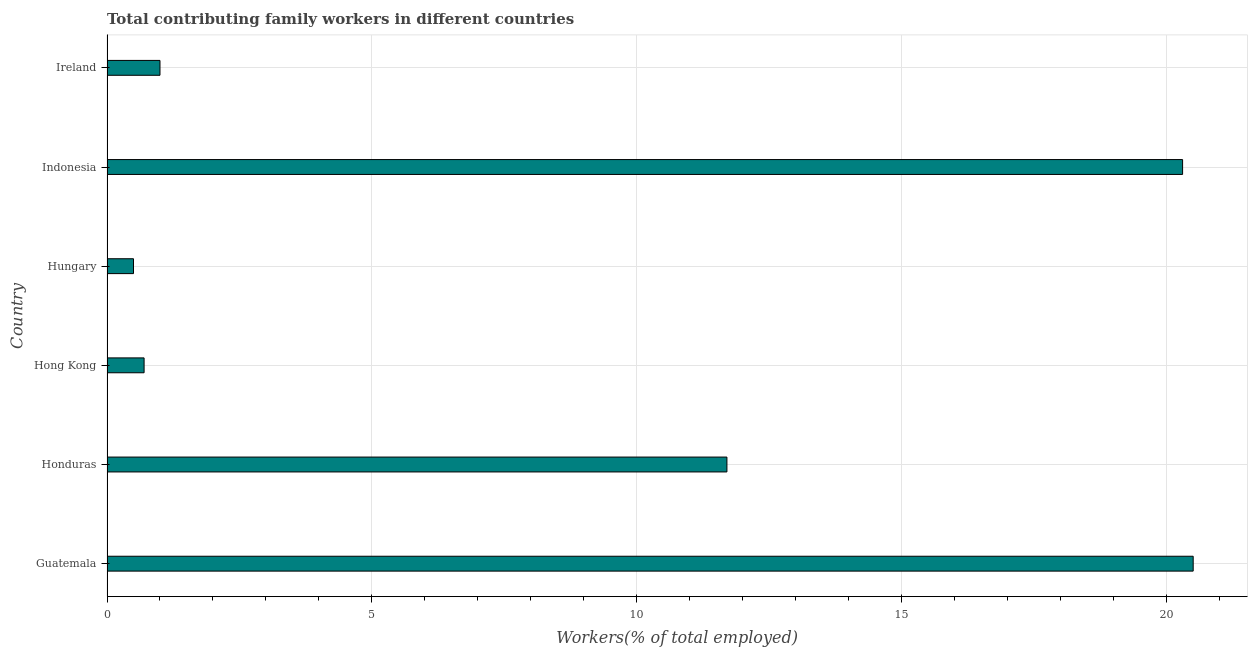Does the graph contain any zero values?
Keep it short and to the point. No. Does the graph contain grids?
Make the answer very short. Yes. What is the title of the graph?
Make the answer very short. Total contributing family workers in different countries. What is the label or title of the X-axis?
Offer a terse response. Workers(% of total employed). What is the contributing family workers in Hong Kong?
Keep it short and to the point. 0.7. Across all countries, what is the maximum contributing family workers?
Ensure brevity in your answer.  20.5. Across all countries, what is the minimum contributing family workers?
Ensure brevity in your answer.  0.5. In which country was the contributing family workers maximum?
Provide a short and direct response. Guatemala. In which country was the contributing family workers minimum?
Your response must be concise. Hungary. What is the sum of the contributing family workers?
Your answer should be compact. 54.7. What is the difference between the contributing family workers in Indonesia and Ireland?
Ensure brevity in your answer.  19.3. What is the average contributing family workers per country?
Your response must be concise. 9.12. What is the median contributing family workers?
Your answer should be compact. 6.35. What is the ratio of the contributing family workers in Guatemala to that in Ireland?
Keep it short and to the point. 20.5. Is the difference between the contributing family workers in Guatemala and Hungary greater than the difference between any two countries?
Ensure brevity in your answer.  Yes. What is the difference between the highest and the second highest contributing family workers?
Provide a succinct answer. 0.2. What is the difference between the highest and the lowest contributing family workers?
Keep it short and to the point. 20. In how many countries, is the contributing family workers greater than the average contributing family workers taken over all countries?
Your answer should be very brief. 3. How many bars are there?
Your response must be concise. 6. How many countries are there in the graph?
Provide a succinct answer. 6. What is the difference between two consecutive major ticks on the X-axis?
Offer a terse response. 5. Are the values on the major ticks of X-axis written in scientific E-notation?
Keep it short and to the point. No. What is the Workers(% of total employed) of Honduras?
Your answer should be very brief. 11.7. What is the Workers(% of total employed) in Hong Kong?
Ensure brevity in your answer.  0.7. What is the Workers(% of total employed) in Indonesia?
Offer a terse response. 20.3. What is the difference between the Workers(% of total employed) in Guatemala and Honduras?
Offer a terse response. 8.8. What is the difference between the Workers(% of total employed) in Guatemala and Hong Kong?
Your answer should be compact. 19.8. What is the difference between the Workers(% of total employed) in Guatemala and Hungary?
Your answer should be compact. 20. What is the difference between the Workers(% of total employed) in Guatemala and Ireland?
Your response must be concise. 19.5. What is the difference between the Workers(% of total employed) in Honduras and Hungary?
Keep it short and to the point. 11.2. What is the difference between the Workers(% of total employed) in Hong Kong and Indonesia?
Keep it short and to the point. -19.6. What is the difference between the Workers(% of total employed) in Hong Kong and Ireland?
Provide a succinct answer. -0.3. What is the difference between the Workers(% of total employed) in Hungary and Indonesia?
Provide a short and direct response. -19.8. What is the difference between the Workers(% of total employed) in Indonesia and Ireland?
Your answer should be very brief. 19.3. What is the ratio of the Workers(% of total employed) in Guatemala to that in Honduras?
Your response must be concise. 1.75. What is the ratio of the Workers(% of total employed) in Guatemala to that in Hong Kong?
Your response must be concise. 29.29. What is the ratio of the Workers(% of total employed) in Guatemala to that in Ireland?
Your answer should be compact. 20.5. What is the ratio of the Workers(% of total employed) in Honduras to that in Hong Kong?
Your answer should be compact. 16.71. What is the ratio of the Workers(% of total employed) in Honduras to that in Hungary?
Make the answer very short. 23.4. What is the ratio of the Workers(% of total employed) in Honduras to that in Indonesia?
Offer a terse response. 0.58. What is the ratio of the Workers(% of total employed) in Hong Kong to that in Hungary?
Keep it short and to the point. 1.4. What is the ratio of the Workers(% of total employed) in Hong Kong to that in Indonesia?
Provide a succinct answer. 0.03. What is the ratio of the Workers(% of total employed) in Hungary to that in Indonesia?
Keep it short and to the point. 0.03. What is the ratio of the Workers(% of total employed) in Indonesia to that in Ireland?
Provide a short and direct response. 20.3. 